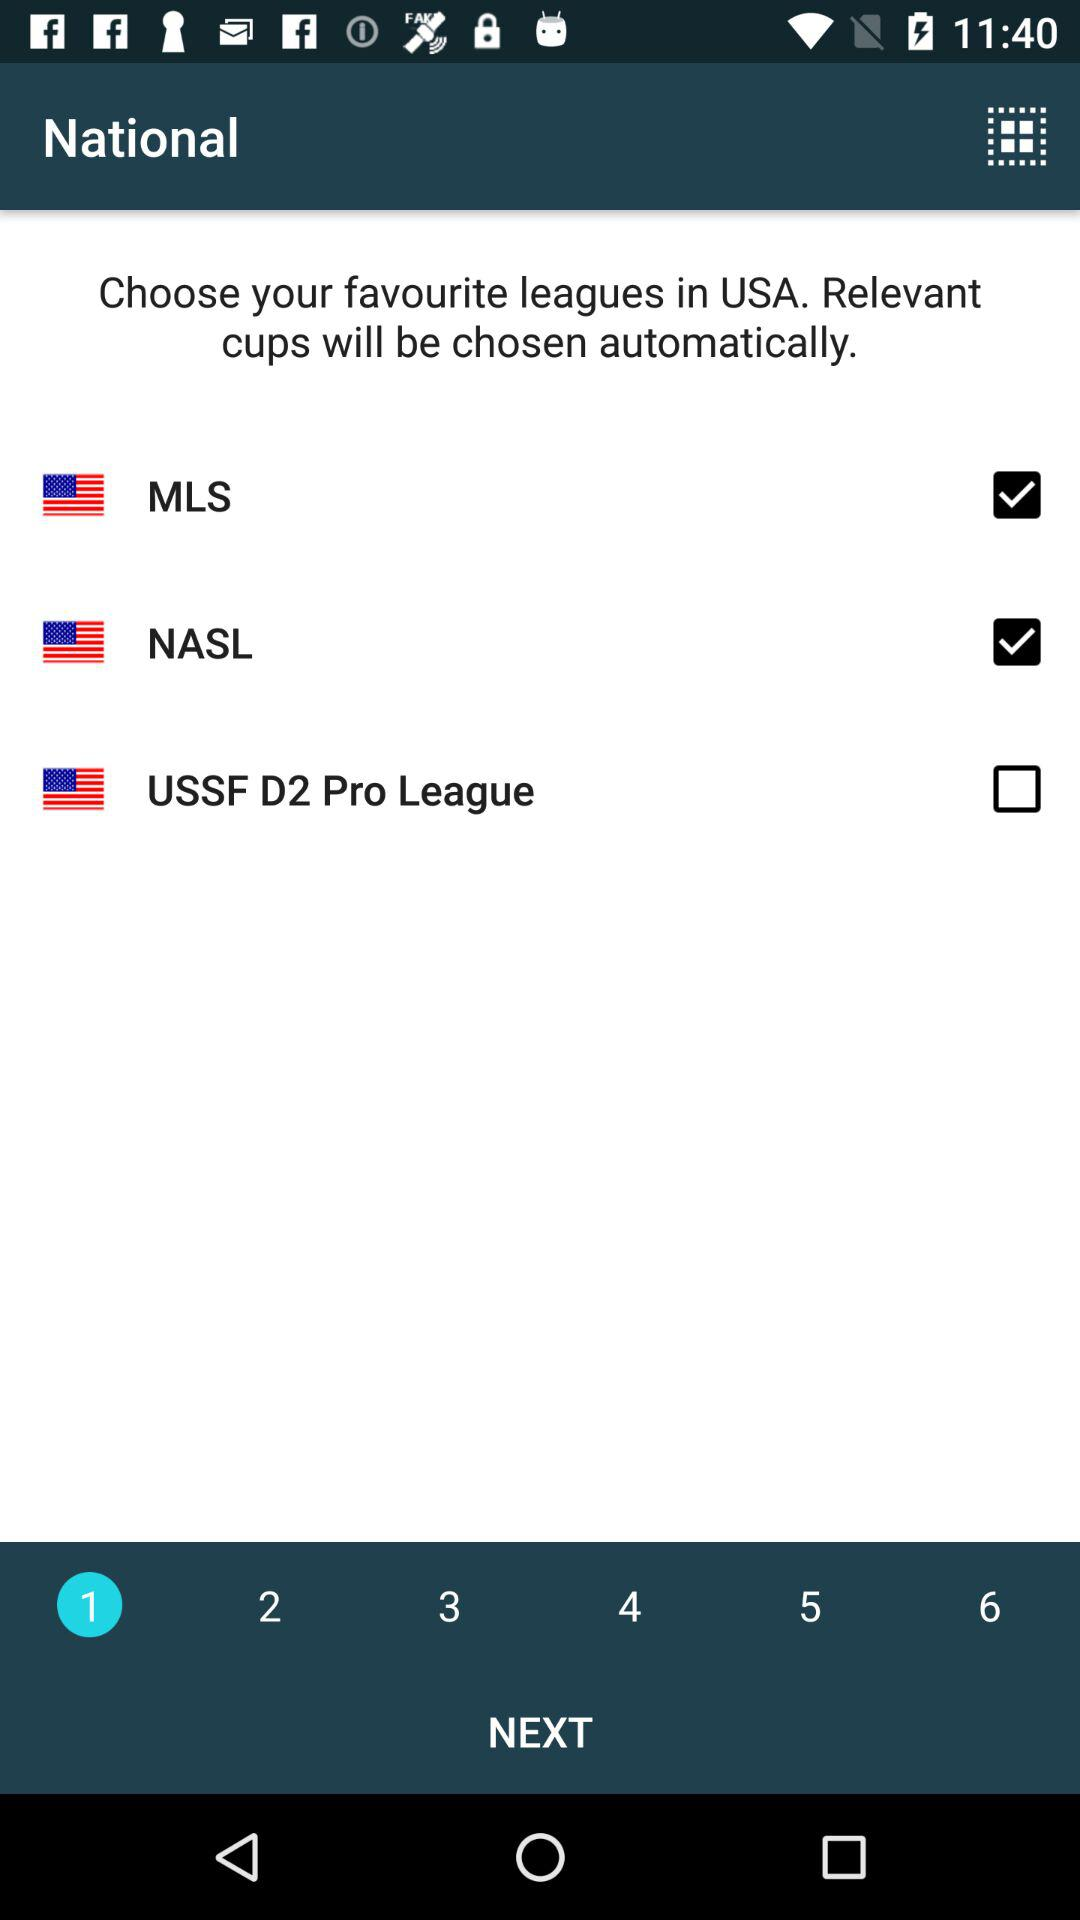Which leagues were selected as the favourite leagues in the USA? The selected leagues were "MLS" and "NASL". 